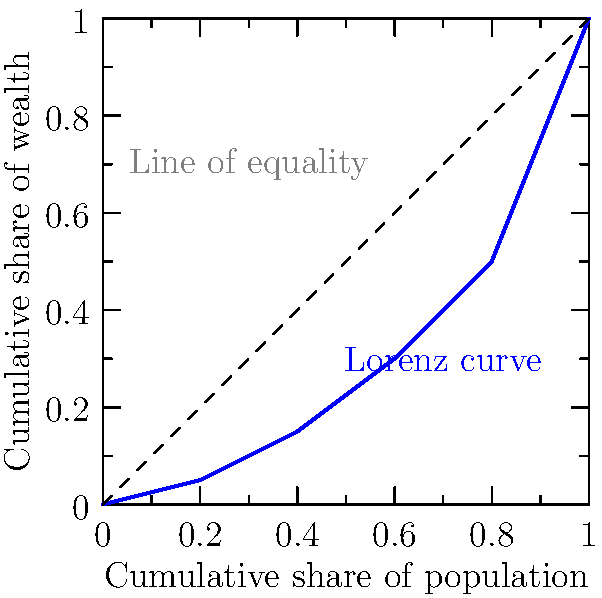Analyze the given Lorenz curve in the context of Marx's theory of capital accumulation. How does this wealth distribution reflect the inherent contradictions in capitalist society, and what implications does the Gini coefficient derived from this curve have for class struggle? Propose a method to calculate the Gini coefficient from this curve and explain its significance in terms of historical materialism. To analyze this Lorenz curve through a Marxist lens, we need to follow these steps:

1. Interpret the Lorenz curve:
   The curve shows a significant deviation from the line of perfect equality, indicating substantial wealth inequality.

2. Connect to Marx's theory of capital accumulation:
   This inequality aligns with Marx's prediction that capitalism leads to the concentration of wealth in fewer hands, as the bourgeoisie accumulates capital at the expense of the proletariat.

3. Calculate the Gini coefficient:
   The Gini coefficient is calculated as the ratio of the area between the line of equality and the Lorenz curve (A) to the total area under the line of equality (A + B).
   
   To estimate A and B:
   a) Divide the area into trapezoids
   b) Calculate the area of each trapezoid
   c) Sum the areas for A and B

   Gini coefficient = A / (A + B)

4. Interpret the Gini coefficient:
   A higher Gini coefficient (closer to 1) indicates greater inequality, supporting Marx's theory of increasing class polarization.

5. Implications for class struggle:
   The high inequality shown by the Lorenz curve and Gini coefficient would, according to Marx, intensify class consciousness and potentially lead to revolutionary action by the proletariat.

6. Historical materialism:
   The Gini coefficient derived from this curve serves as a quantitative measure of the economic base, which, in Marxist theory, determines the superstructure of society, including its political and ideological aspects.

This analysis demonstrates how economic indicators like the Lorenz curve and Gini coefficient can be used to support and quantify Marxist theories of social relations and historical development.
Answer: The Lorenz curve shows significant wealth inequality, supporting Marx's theory of capital accumulation. The Gini coefficient, calculated as the ratio of areas between the curve and equality line, quantifies this inequality. This supports the Marxist view of class polarization and potential for intensified class struggle, demonstrating the economic base's influence on societal superstructure as per historical materialism. 